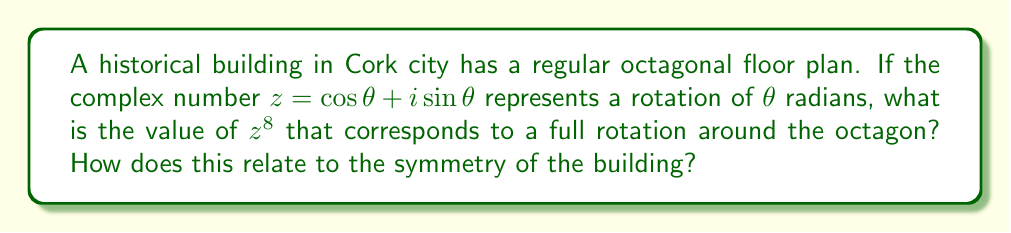Show me your answer to this math problem. Let's approach this step-by-step using De Moivre's theorem:

1) De Moivre's theorem states that for any real number $\theta$ and integer $n$:

   $(\cos \theta + i \sin \theta)^n = \cos(n\theta) + i \sin(n\theta)$

2) In our case, we have $z = \cos \theta + i \sin \theta$ and we're looking for $z^8$.

3) For a regular octagon, each rotation is $\frac{2\pi}{8} = \frac{\pi}{4}$ radians.

4) So, $\theta = \frac{\pi}{4}$

5) Applying De Moivre's theorem:

   $z^8 = (\cos \frac{\pi}{4} + i \sin \frac{\pi}{4})^8 = \cos(8 \cdot \frac{\pi}{4}) + i \sin(8 \cdot \frac{\pi}{4})$

6) Simplify:

   $z^8 = \cos(2\pi) + i \sin(2\pi)$

7) We know that $\cos(2\pi) = 1$ and $\sin(2\pi) = 0$, so:

   $z^8 = 1 + 0i = 1$

8) This result of 1 indicates a full rotation, returning to the starting point.

9) In terms of symmetry, this shows that the building has 8-fold rotational symmetry. After 8 equal rotations, we return to the original position, which is a characteristic of regular octagons.
Answer: $z^8 = 1$, indicating 8-fold rotational symmetry 